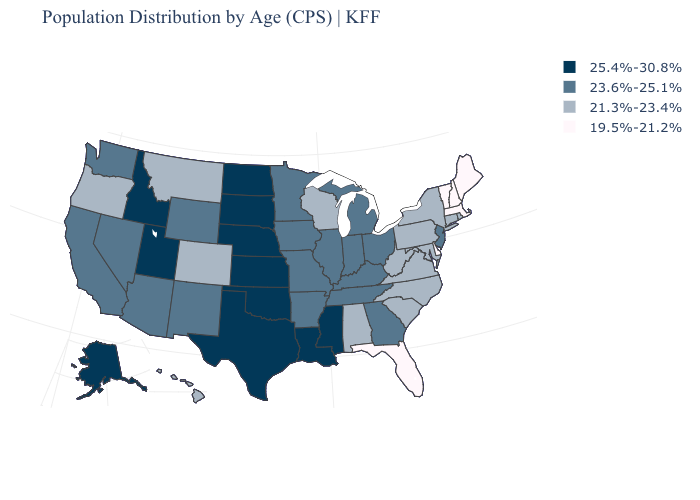What is the value of Massachusetts?
Be succinct. 19.5%-21.2%. Does the first symbol in the legend represent the smallest category?
Quick response, please. No. Does Rhode Island have the lowest value in the USA?
Write a very short answer. No. Name the states that have a value in the range 21.3%-23.4%?
Be succinct. Alabama, Colorado, Connecticut, Hawaii, Maryland, Montana, New York, North Carolina, Oregon, Pennsylvania, Rhode Island, South Carolina, Virginia, West Virginia, Wisconsin. How many symbols are there in the legend?
Short answer required. 4. What is the value of Wyoming?
Be succinct. 23.6%-25.1%. Which states have the highest value in the USA?
Answer briefly. Alaska, Idaho, Kansas, Louisiana, Mississippi, Nebraska, North Dakota, Oklahoma, South Dakota, Texas, Utah. Which states have the highest value in the USA?
Keep it brief. Alaska, Idaho, Kansas, Louisiana, Mississippi, Nebraska, North Dakota, Oklahoma, South Dakota, Texas, Utah. Among the states that border Wisconsin , which have the highest value?
Quick response, please. Illinois, Iowa, Michigan, Minnesota. Does Virginia have the highest value in the USA?
Quick response, please. No. Does New Hampshire have the lowest value in the Northeast?
Be succinct. Yes. Does the map have missing data?
Be succinct. No. Name the states that have a value in the range 25.4%-30.8%?
Keep it brief. Alaska, Idaho, Kansas, Louisiana, Mississippi, Nebraska, North Dakota, Oklahoma, South Dakota, Texas, Utah. Which states have the lowest value in the USA?
Keep it brief. Delaware, Florida, Maine, Massachusetts, New Hampshire, Vermont. Does Wisconsin have a lower value than Oregon?
Write a very short answer. No. 